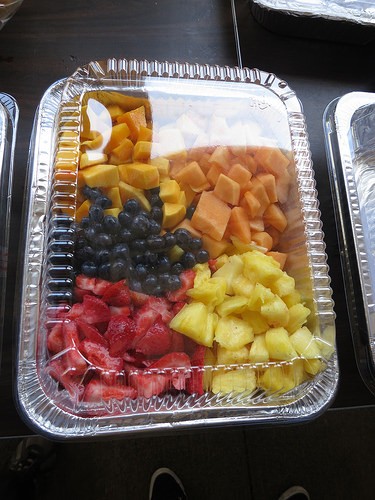<image>
Is the pineapple on the strawberries? Yes. Looking at the image, I can see the pineapple is positioned on top of the strawberries, with the strawberries providing support. Is there a lid under the fruit? No. The lid is not positioned under the fruit. The vertical relationship between these objects is different. 